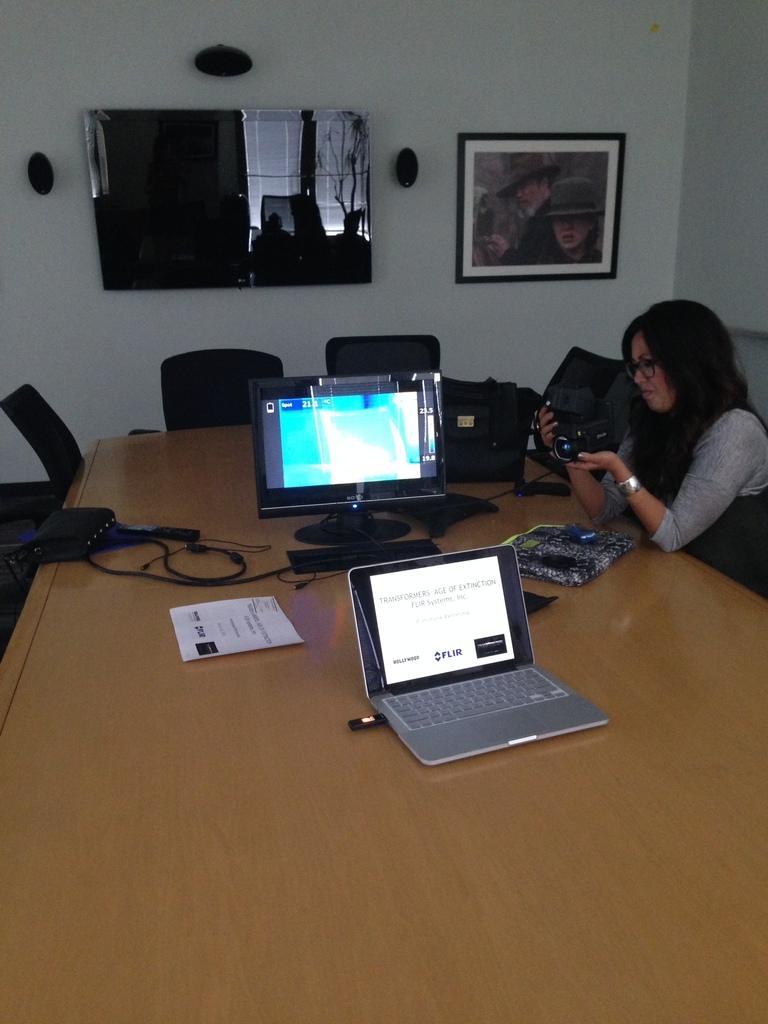How would you summarize this image in a sentence or two? On the background we can see photo frame, television screen over a wall. Here we can see a woman sitting on chair in front of a table and on the table we can see a monitor, keyboard, wire , laptop with pen drive , paper and a bag. We can see few empty chairs. 